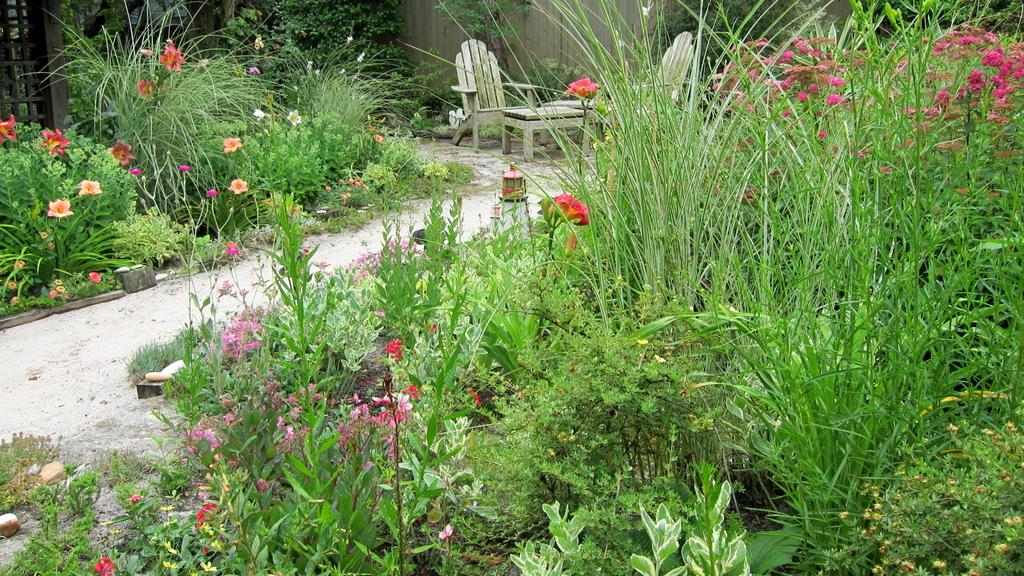What type of outdoor space is shown in the image? There is a garden in the image. What can be found in the garden? The garden contains plants, flowers, and grass. What is located in the middle of the garden? There is a table and chairs in the middle of the garden. How many children are playing with the fang in the garden? There are no children or fangs present in the image; it only shows a garden with plants, flowers, grass, a table, and chairs. 